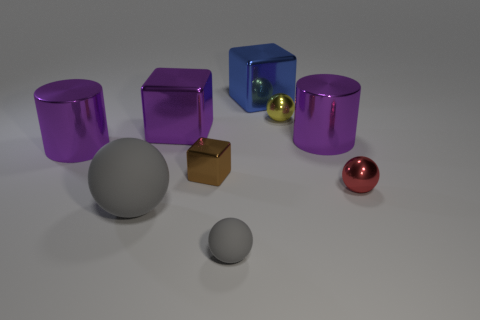There is a shiny cylinder on the left side of the large blue metal block; is it the same color as the large object to the right of the yellow metallic thing?
Ensure brevity in your answer.  Yes. What number of other matte objects are the same color as the large rubber object?
Your answer should be very brief. 1. Is the number of metallic blocks that are on the left side of the large blue metal cube greater than the number of big purple shiny cylinders on the left side of the large gray sphere?
Your answer should be compact. Yes. What is the material of the tiny gray thing?
Keep it short and to the point. Rubber. Are there any yellow metal spheres that have the same size as the blue metal object?
Your response must be concise. No. There is a cube that is the same size as the red thing; what is it made of?
Offer a terse response. Metal. What number of purple metallic cubes are there?
Provide a short and direct response. 1. What size is the metal sphere behind the red shiny ball?
Offer a very short reply. Small. Are there the same number of metal cubes on the right side of the big blue block and small yellow matte spheres?
Give a very brief answer. Yes. Are there any gray objects of the same shape as the yellow shiny thing?
Your response must be concise. Yes. 